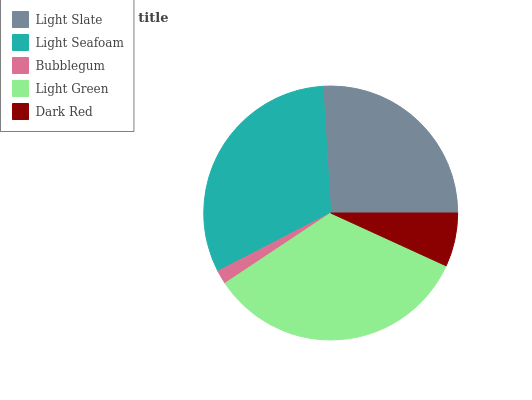Is Bubblegum the minimum?
Answer yes or no. Yes. Is Light Green the maximum?
Answer yes or no. Yes. Is Light Seafoam the minimum?
Answer yes or no. No. Is Light Seafoam the maximum?
Answer yes or no. No. Is Light Seafoam greater than Light Slate?
Answer yes or no. Yes. Is Light Slate less than Light Seafoam?
Answer yes or no. Yes. Is Light Slate greater than Light Seafoam?
Answer yes or no. No. Is Light Seafoam less than Light Slate?
Answer yes or no. No. Is Light Slate the high median?
Answer yes or no. Yes. Is Light Slate the low median?
Answer yes or no. Yes. Is Light Green the high median?
Answer yes or no. No. Is Light Seafoam the low median?
Answer yes or no. No. 